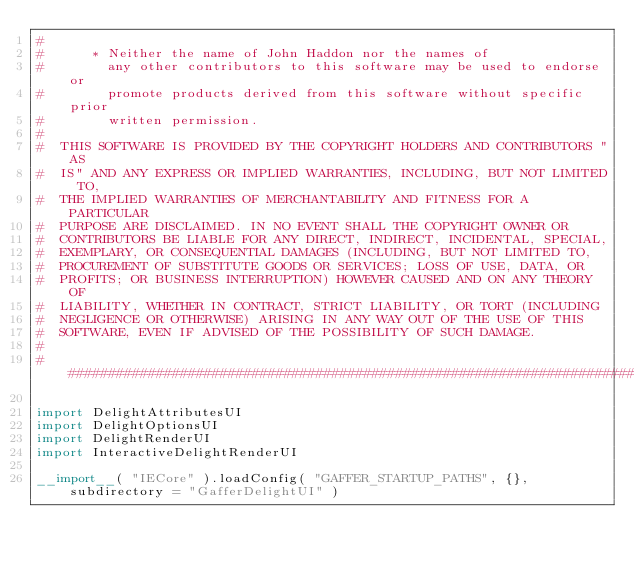Convert code to text. <code><loc_0><loc_0><loc_500><loc_500><_Python_>#
#      * Neither the name of John Haddon nor the names of
#        any other contributors to this software may be used to endorse or
#        promote products derived from this software without specific prior
#        written permission.
#
#  THIS SOFTWARE IS PROVIDED BY THE COPYRIGHT HOLDERS AND CONTRIBUTORS "AS
#  IS" AND ANY EXPRESS OR IMPLIED WARRANTIES, INCLUDING, BUT NOT LIMITED TO,
#  THE IMPLIED WARRANTIES OF MERCHANTABILITY AND FITNESS FOR A PARTICULAR
#  PURPOSE ARE DISCLAIMED. IN NO EVENT SHALL THE COPYRIGHT OWNER OR
#  CONTRIBUTORS BE LIABLE FOR ANY DIRECT, INDIRECT, INCIDENTAL, SPECIAL,
#  EXEMPLARY, OR CONSEQUENTIAL DAMAGES (INCLUDING, BUT NOT LIMITED TO,
#  PROCUREMENT OF SUBSTITUTE GOODS OR SERVICES; LOSS OF USE, DATA, OR
#  PROFITS; OR BUSINESS INTERRUPTION) HOWEVER CAUSED AND ON ANY THEORY OF
#  LIABILITY, WHETHER IN CONTRACT, STRICT LIABILITY, OR TORT (INCLUDING
#  NEGLIGENCE OR OTHERWISE) ARISING IN ANY WAY OUT OF THE USE OF THIS
#  SOFTWARE, EVEN IF ADVISED OF THE POSSIBILITY OF SUCH DAMAGE.
#
##########################################################################

import DelightAttributesUI
import DelightOptionsUI
import DelightRenderUI
import InteractiveDelightRenderUI

__import__( "IECore" ).loadConfig( "GAFFER_STARTUP_PATHS", {}, subdirectory = "GafferDelightUI" )
</code> 